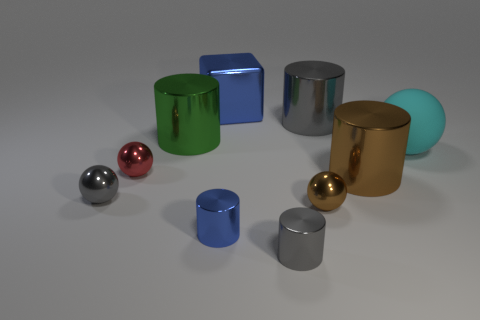Subtract all brown spheres. Subtract all gray blocks. How many spheres are left? 3 Subtract all blocks. How many objects are left? 9 Add 1 tiny cylinders. How many tiny cylinders are left? 3 Add 4 red metal spheres. How many red metal spheres exist? 5 Subtract 0 green blocks. How many objects are left? 10 Subtract all large gray blocks. Subtract all red objects. How many objects are left? 9 